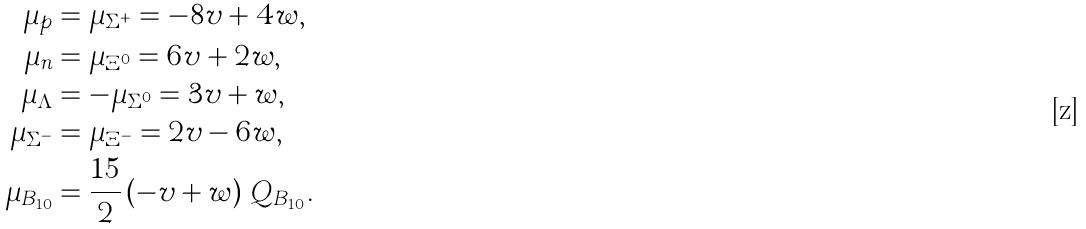Convert formula to latex. <formula><loc_0><loc_0><loc_500><loc_500>\mu _ { p } & = \mu _ { \Sigma ^ { + } } = - 8 v + 4 w , \\ \mu _ { n } & = \mu _ { \Xi ^ { 0 } } = 6 v + 2 w , \\ \mu _ { \Lambda } & = - \mu _ { \Sigma ^ { 0 } } = 3 v + w , \\ \mu _ { \Sigma ^ { - } } & = \mu _ { \Xi ^ { - } } = 2 v - 6 w , \\ \mu _ { B _ { 1 0 } } & = \frac { 1 5 } { 2 } \left ( - v + w \right ) \, Q _ { B _ { 1 0 } } .</formula> 